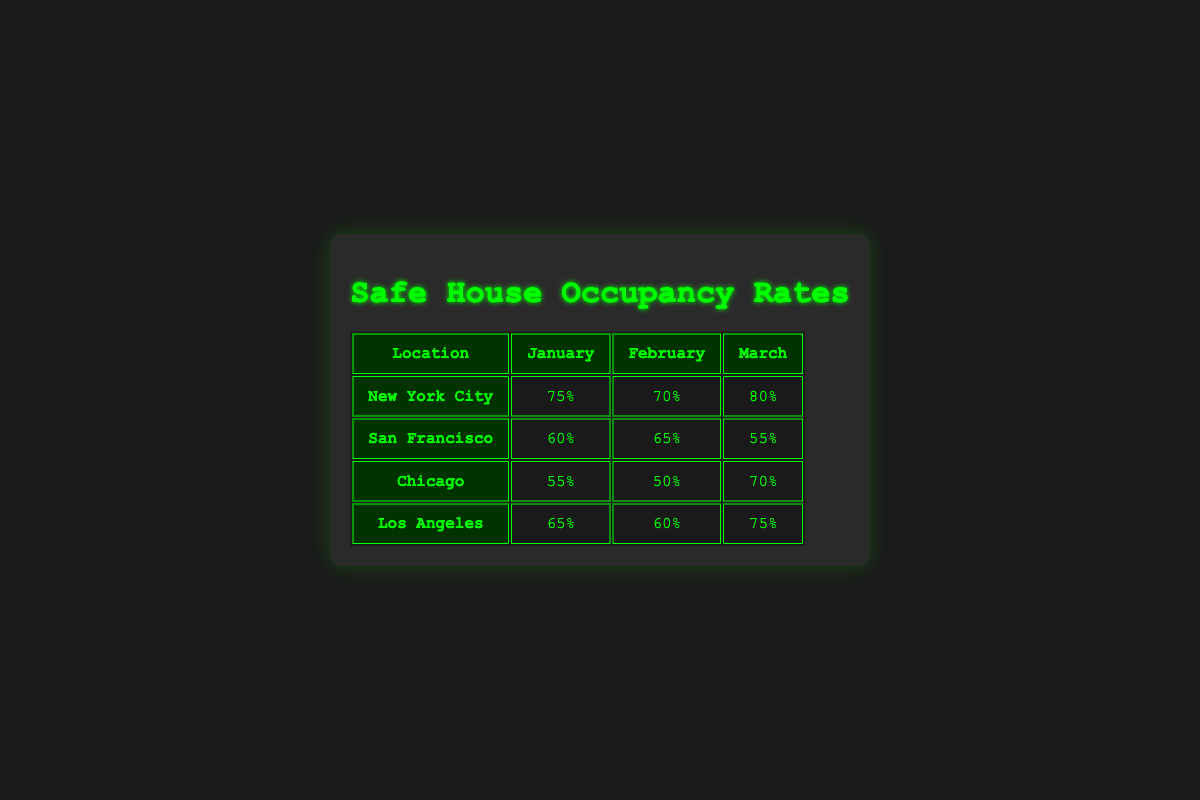What is the occupancy rate for safe houses in New York City in March? The table shows that for New York City in March, the occupancy rate is listed as 80%.
Answer: 80% Which location had the highest occupancy rate in January? In January, the occupancy rates are: New York City (75%), San Francisco (60%), Chicago (55%), and Los Angeles (65%). New York City has the highest occupancy rate at 75%.
Answer: New York City What is the average occupancy rate for Los Angeles across the three months? The occupancy rates for Los Angeles are: January (65%), February (60%), and March (75%). The sum is 65 + 60 + 75 = 200. Dividing by 3 gives an average of 200/3 = 66.67.
Answer: 66.67 Did San Francisco have a higher occupancy rate in February than in January? For San Francisco, the occupancy rate in January is 60% and in February is 65%. Since 65% is greater than 60%, the statement is true.
Answer: Yes Which location experienced the largest increase in occupancy rate from February to March? The changes in rates from February to March are: New York City (70% to 80%, an increase of 10%), San Francisco (65% to 55%, a decrease), Chicago (50% to 70%, an increase of 20%), and Los Angeles (60% to 75%, an increase of 15%). Chicago had the largest increase of 20%.
Answer: Chicago What is the total occupancy rate for safe houses in Chicago over the three months? The occupancy rates for Chicago are: January (55%), February (50%), and March (70%). The total is 55 + 50 + 70 = 175.
Answer: 175 Is the occupancy rate in February for any location lower than 60%? The occupancy rates in February are: New York City (70%), San Francisco (65%), Chicago (50%), and Los Angeles (60%). Chicago's occupancy rate of 50% is lower than 60%.
Answer: Yes What was the difference in occupancy rates between January and March for Los Angeles? For Los Angeles, the January rate is 65% and the March rate is 75%. The difference is 75% - 65% = 10%.
Answer: 10% 